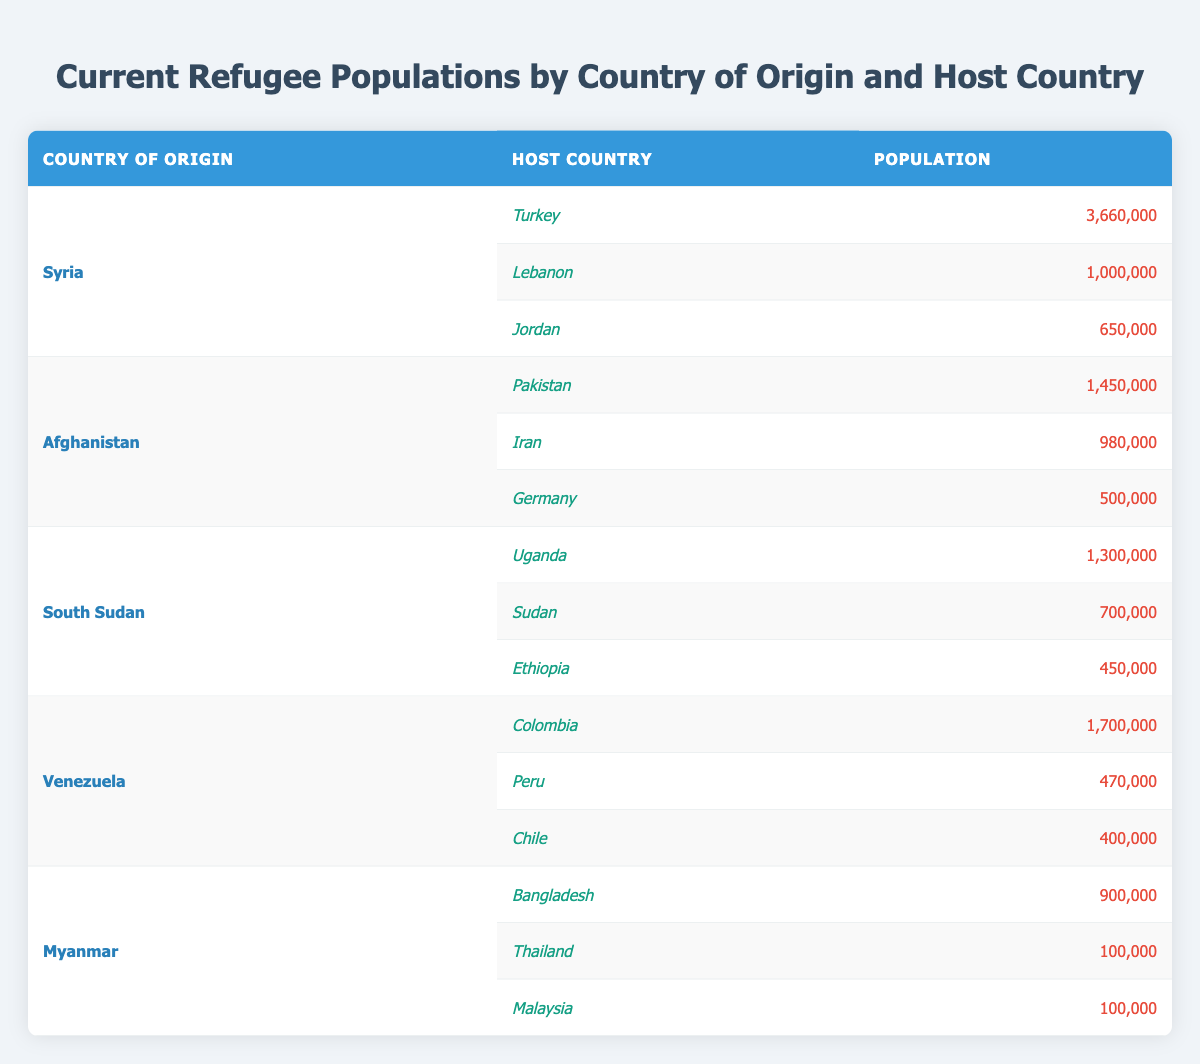What is the total refugee population from Syria? The table shows three host countries for Syrian refugees: Turkey (3,660,000), Lebanon (1,000,000), and Jordan (650,000). Summing these values: 3,660,000 + 1,000,000 + 650,000 = 5,310,000.
Answer: 5,310,000 Which host country has the highest number of refugees from Afghanistan? The table lists three host countries for Afghan refugees: Pakistan (1,450,000), Iran (980,000), and Germany (500,000). The largest number is in Pakistan with 1,450,000.
Answer: Pakistan How many refugees from South Sudan are hosted in Uganda? The table specifies that Uganda hosts 1,300,000 refugees from South Sudan.
Answer: 1,300,000 Is the total number of Venezuelan refugees in Peru greater than the number in Chile? The table shows Venezuela has 470,000 refugees in Peru and 400,000 in Chile. Since 470,000 is greater than 400,000, the statement is true.
Answer: Yes What is the combined refugee population in Turkey and Lebanon from Syria? According to the table, Turkey has 3,660,000 and Lebanon has 1,000,000 Syrian refugees. Adding these populations gives 3,660,000 + 1,000,000 = 4,660,000.
Answer: 4,660,000 How does the population of South Sudanese refugees in Sudan compare to that in Ethiopia? The table indicates Sudan hosts 700,000 and Ethiopia hosts 450,000 refugees from South Sudan. Thus, the population in Sudan (700,000) is greater than in Ethiopia (450,000).
Answer: Sudan has more refugees What is the total population of refugees from Myanmar in host countries? The table lists three host countries for Myanmar: Bangladesh (900,000), Thailand (100,000), and Malaysia (100,000). Summing these values gives: 900,000 + 100,000 + 100,000 = 1,100,000.
Answer: 1,100,000 Which country has the lowest number of refugees hosted from Afghanistan? The table shows the number of Afghan refugees hosted as follows: Pakistan (1,450,000), Iran (980,000), and Germany (500,000). Germany has the least with 500,000.
Answer: Germany What is the total number of refugees from Venezuela hosted in all listed countries? The refugee populations from Venezuela host countries are: Colombia (1,700,000), Peru (470,000), and Chile (400,000). Totaling these gives: 1,700,000 + 470,000 + 400,000 = 2,570,000.
Answer: 2,570,000 Are there more refugees from Syria or from South Sudan in total? Total Syrian refugees amount to 5,310,000, while South Sudanese refugees total 2,450,000 (1,300,000 in Uganda, 700,000 in Sudan, and 450,000 in Ethiopia). Since 5,310,000 is greater than 2,450,000, the statement is true.
Answer: More from Syria 